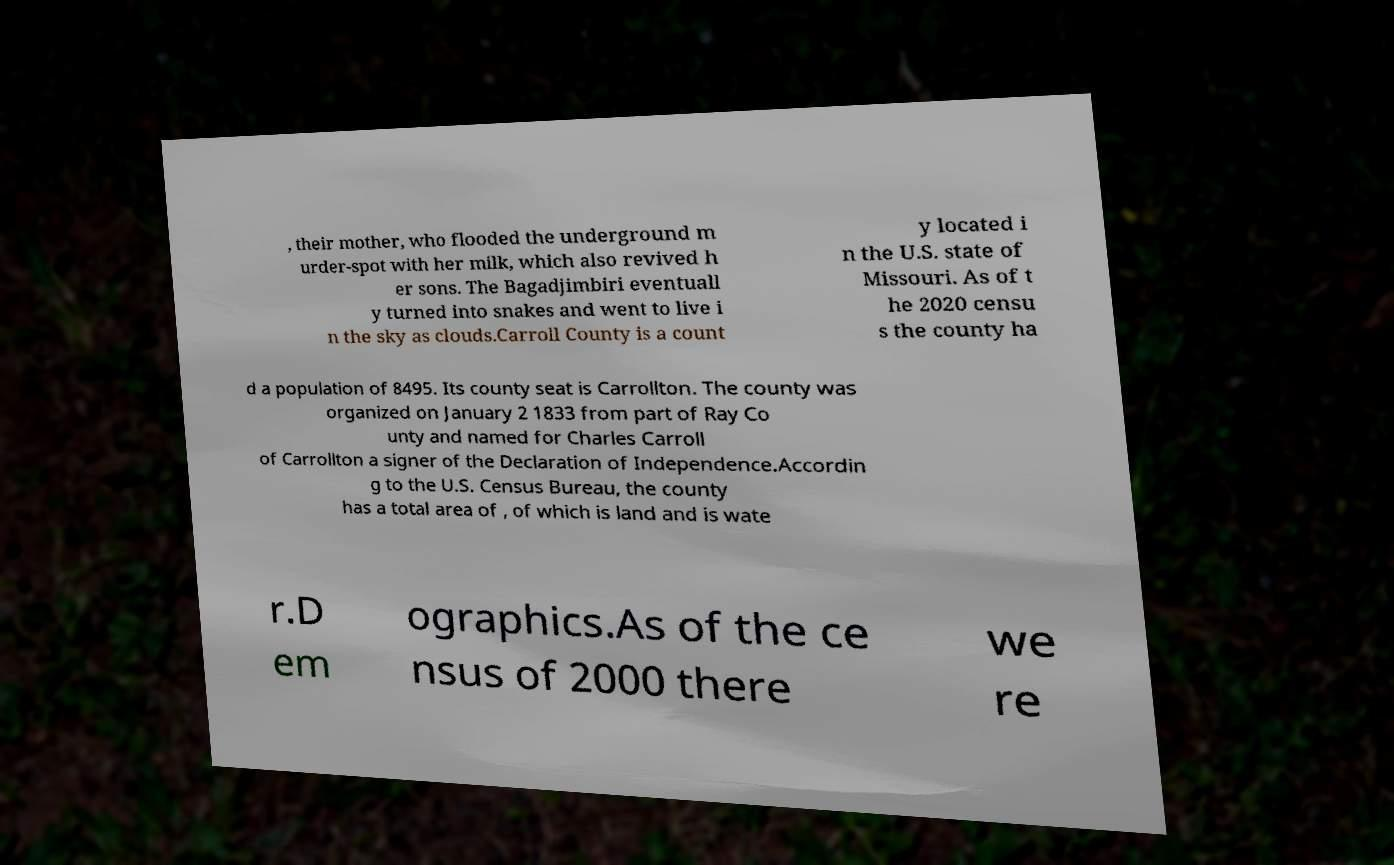Can you read and provide the text displayed in the image?This photo seems to have some interesting text. Can you extract and type it out for me? , their mother, who flooded the underground m urder-spot with her milk, which also revived h er sons. The Bagadjimbiri eventuall y turned into snakes and went to live i n the sky as clouds.Carroll County is a count y located i n the U.S. state of Missouri. As of t he 2020 censu s the county ha d a population of 8495. Its county seat is Carrollton. The county was organized on January 2 1833 from part of Ray Co unty and named for Charles Carroll of Carrollton a signer of the Declaration of Independence.Accordin g to the U.S. Census Bureau, the county has a total area of , of which is land and is wate r.D em ographics.As of the ce nsus of 2000 there we re 